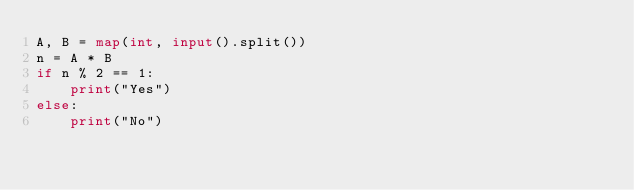<code> <loc_0><loc_0><loc_500><loc_500><_Python_>A, B = map(int, input().split())
n = A * B
if n % 2 == 1:
    print("Yes")
else:
    print("No")</code> 